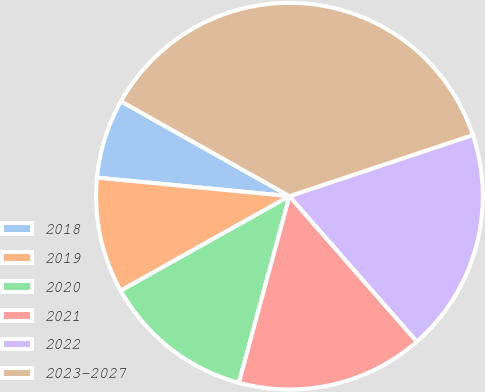Convert chart to OTSL. <chart><loc_0><loc_0><loc_500><loc_500><pie_chart><fcel>2018<fcel>2019<fcel>2020<fcel>2021<fcel>2022<fcel>2023-2027<nl><fcel>6.64%<fcel>9.65%<fcel>12.66%<fcel>15.66%<fcel>18.67%<fcel>36.71%<nl></chart> 